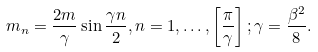<formula> <loc_0><loc_0><loc_500><loc_500>m _ { n } = \frac { 2 m } { \gamma } \sin \frac { \gamma n } { 2 } , n = 1 , \dots , \left [ \frac { \pi } { \gamma } \right ] ; \gamma = \frac { \beta ^ { 2 } } { 8 } .</formula> 